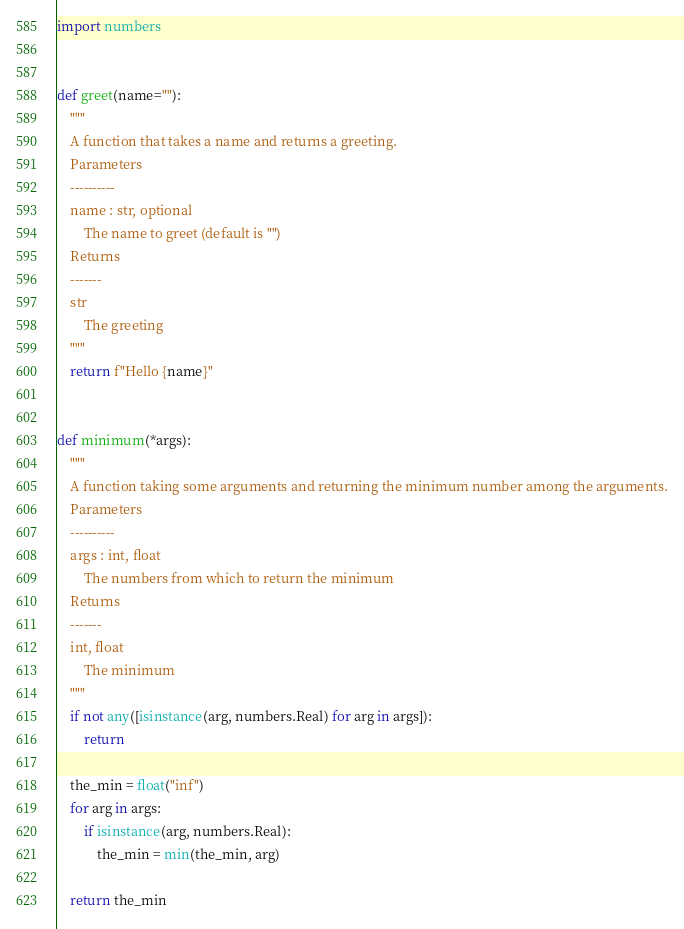<code> <loc_0><loc_0><loc_500><loc_500><_Python_>
import numbers


def greet(name=""):
    """
    A function that takes a name and returns a greeting.
    Parameters
    ----------
    name : str, optional
        The name to greet (default is "")
    Returns
    -------
    str
        The greeting
    """
    return f"Hello {name}"


def minimum(*args):
    """
    A function taking some arguments and returning the minimum number among the arguments.
    Parameters
    ----------
    args : int, float
        The numbers from which to return the minimum
    Returns
    -------
    int, float
        The minimum
    """
    if not any([isinstance(arg, numbers.Real) for arg in args]):
        return

    the_min = float("inf")
    for arg in args:
        if isinstance(arg, numbers.Real):
            the_min = min(the_min, arg)

    return the_min
</code> 